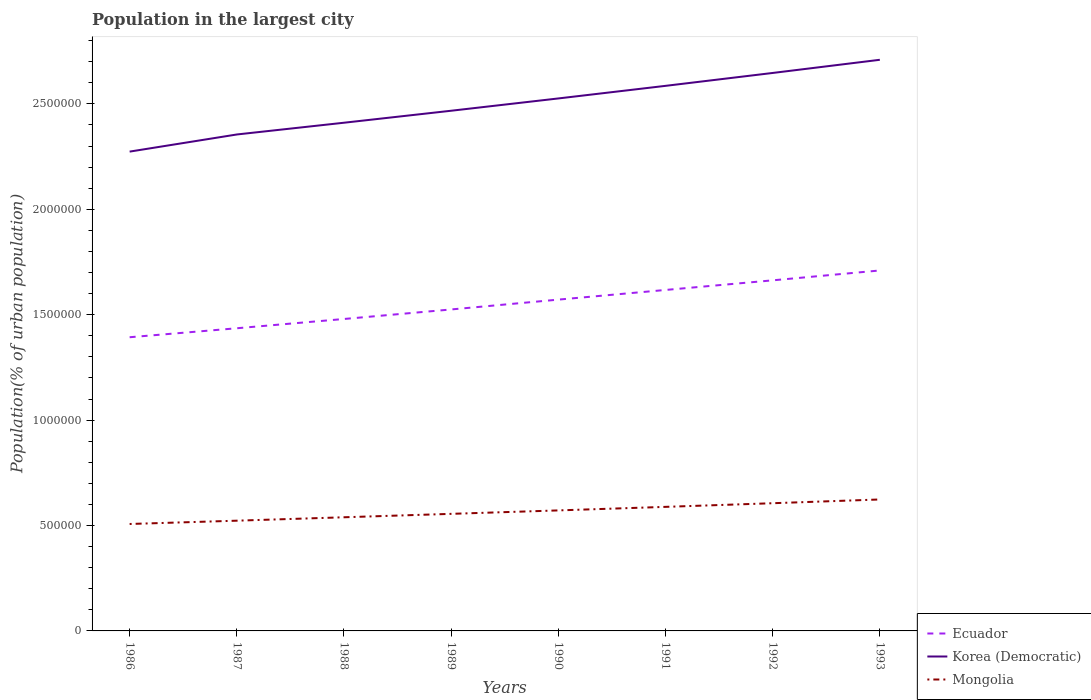Does the line corresponding to Ecuador intersect with the line corresponding to Mongolia?
Provide a succinct answer. No. Is the number of lines equal to the number of legend labels?
Offer a terse response. Yes. Across all years, what is the maximum population in the largest city in Korea (Democratic)?
Keep it short and to the point. 2.27e+06. What is the total population in the largest city in Mongolia in the graph?
Your answer should be compact. -3.26e+04. What is the difference between the highest and the second highest population in the largest city in Korea (Democratic)?
Offer a very short reply. 4.36e+05. How many years are there in the graph?
Provide a short and direct response. 8. What is the difference between two consecutive major ticks on the Y-axis?
Provide a succinct answer. 5.00e+05. Where does the legend appear in the graph?
Your response must be concise. Bottom right. What is the title of the graph?
Ensure brevity in your answer.  Population in the largest city. What is the label or title of the Y-axis?
Your answer should be very brief. Population(% of urban population). What is the Population(% of urban population) of Ecuador in 1986?
Ensure brevity in your answer.  1.39e+06. What is the Population(% of urban population) of Korea (Democratic) in 1986?
Your response must be concise. 2.27e+06. What is the Population(% of urban population) in Mongolia in 1986?
Ensure brevity in your answer.  5.07e+05. What is the Population(% of urban population) in Ecuador in 1987?
Your answer should be compact. 1.44e+06. What is the Population(% of urban population) in Korea (Democratic) in 1987?
Provide a short and direct response. 2.36e+06. What is the Population(% of urban population) in Mongolia in 1987?
Offer a very short reply. 5.23e+05. What is the Population(% of urban population) in Ecuador in 1988?
Your response must be concise. 1.48e+06. What is the Population(% of urban population) in Korea (Democratic) in 1988?
Make the answer very short. 2.41e+06. What is the Population(% of urban population) of Mongolia in 1988?
Offer a very short reply. 5.39e+05. What is the Population(% of urban population) in Ecuador in 1989?
Keep it short and to the point. 1.52e+06. What is the Population(% of urban population) in Korea (Democratic) in 1989?
Provide a short and direct response. 2.47e+06. What is the Population(% of urban population) in Mongolia in 1989?
Your answer should be compact. 5.55e+05. What is the Population(% of urban population) of Ecuador in 1990?
Your response must be concise. 1.57e+06. What is the Population(% of urban population) in Korea (Democratic) in 1990?
Give a very brief answer. 2.53e+06. What is the Population(% of urban population) of Mongolia in 1990?
Your answer should be compact. 5.72e+05. What is the Population(% of urban population) of Ecuador in 1991?
Your answer should be compact. 1.62e+06. What is the Population(% of urban population) of Korea (Democratic) in 1991?
Your answer should be compact. 2.59e+06. What is the Population(% of urban population) of Mongolia in 1991?
Ensure brevity in your answer.  5.88e+05. What is the Population(% of urban population) in Ecuador in 1992?
Offer a terse response. 1.66e+06. What is the Population(% of urban population) of Korea (Democratic) in 1992?
Give a very brief answer. 2.65e+06. What is the Population(% of urban population) in Mongolia in 1992?
Your answer should be very brief. 6.06e+05. What is the Population(% of urban population) of Ecuador in 1993?
Provide a succinct answer. 1.71e+06. What is the Population(% of urban population) of Korea (Democratic) in 1993?
Give a very brief answer. 2.71e+06. What is the Population(% of urban population) of Mongolia in 1993?
Offer a terse response. 6.24e+05. Across all years, what is the maximum Population(% of urban population) of Ecuador?
Ensure brevity in your answer.  1.71e+06. Across all years, what is the maximum Population(% of urban population) of Korea (Democratic)?
Offer a very short reply. 2.71e+06. Across all years, what is the maximum Population(% of urban population) of Mongolia?
Ensure brevity in your answer.  6.24e+05. Across all years, what is the minimum Population(% of urban population) of Ecuador?
Your response must be concise. 1.39e+06. Across all years, what is the minimum Population(% of urban population) of Korea (Democratic)?
Offer a terse response. 2.27e+06. Across all years, what is the minimum Population(% of urban population) of Mongolia?
Offer a terse response. 5.07e+05. What is the total Population(% of urban population) in Ecuador in the graph?
Your response must be concise. 1.24e+07. What is the total Population(% of urban population) of Korea (Democratic) in the graph?
Your response must be concise. 2.00e+07. What is the total Population(% of urban population) of Mongolia in the graph?
Offer a terse response. 4.51e+06. What is the difference between the Population(% of urban population) of Ecuador in 1986 and that in 1987?
Your response must be concise. -4.26e+04. What is the difference between the Population(% of urban population) of Korea (Democratic) in 1986 and that in 1987?
Your response must be concise. -8.12e+04. What is the difference between the Population(% of urban population) of Mongolia in 1986 and that in 1987?
Your answer should be compact. -1.57e+04. What is the difference between the Population(% of urban population) of Ecuador in 1986 and that in 1988?
Provide a succinct answer. -8.66e+04. What is the difference between the Population(% of urban population) of Korea (Democratic) in 1986 and that in 1988?
Make the answer very short. -1.37e+05. What is the difference between the Population(% of urban population) of Mongolia in 1986 and that in 1988?
Keep it short and to the point. -3.19e+04. What is the difference between the Population(% of urban population) in Ecuador in 1986 and that in 1989?
Keep it short and to the point. -1.32e+05. What is the difference between the Population(% of urban population) in Korea (Democratic) in 1986 and that in 1989?
Your answer should be compact. -1.94e+05. What is the difference between the Population(% of urban population) of Mongolia in 1986 and that in 1989?
Make the answer very short. -4.81e+04. What is the difference between the Population(% of urban population) in Ecuador in 1986 and that in 1990?
Your response must be concise. -1.78e+05. What is the difference between the Population(% of urban population) in Korea (Democratic) in 1986 and that in 1990?
Give a very brief answer. -2.52e+05. What is the difference between the Population(% of urban population) in Mongolia in 1986 and that in 1990?
Give a very brief answer. -6.44e+04. What is the difference between the Population(% of urban population) of Ecuador in 1986 and that in 1991?
Provide a short and direct response. -2.24e+05. What is the difference between the Population(% of urban population) in Korea (Democratic) in 1986 and that in 1991?
Your response must be concise. -3.12e+05. What is the difference between the Population(% of urban population) in Mongolia in 1986 and that in 1991?
Keep it short and to the point. -8.12e+04. What is the difference between the Population(% of urban population) in Ecuador in 1986 and that in 1992?
Ensure brevity in your answer.  -2.70e+05. What is the difference between the Population(% of urban population) of Korea (Democratic) in 1986 and that in 1992?
Your answer should be very brief. -3.73e+05. What is the difference between the Population(% of urban population) in Mongolia in 1986 and that in 1992?
Ensure brevity in your answer.  -9.85e+04. What is the difference between the Population(% of urban population) in Ecuador in 1986 and that in 1993?
Provide a succinct answer. -3.17e+05. What is the difference between the Population(% of urban population) in Korea (Democratic) in 1986 and that in 1993?
Offer a terse response. -4.36e+05. What is the difference between the Population(% of urban population) in Mongolia in 1986 and that in 1993?
Offer a terse response. -1.16e+05. What is the difference between the Population(% of urban population) of Ecuador in 1987 and that in 1988?
Ensure brevity in your answer.  -4.40e+04. What is the difference between the Population(% of urban population) of Korea (Democratic) in 1987 and that in 1988?
Your response must be concise. -5.57e+04. What is the difference between the Population(% of urban population) in Mongolia in 1987 and that in 1988?
Offer a very short reply. -1.62e+04. What is the difference between the Population(% of urban population) of Ecuador in 1987 and that in 1989?
Offer a terse response. -8.92e+04. What is the difference between the Population(% of urban population) in Korea (Democratic) in 1987 and that in 1989?
Make the answer very short. -1.13e+05. What is the difference between the Population(% of urban population) of Mongolia in 1987 and that in 1989?
Ensure brevity in your answer.  -3.24e+04. What is the difference between the Population(% of urban population) of Ecuador in 1987 and that in 1990?
Your answer should be very brief. -1.36e+05. What is the difference between the Population(% of urban population) of Korea (Democratic) in 1987 and that in 1990?
Keep it short and to the point. -1.71e+05. What is the difference between the Population(% of urban population) of Mongolia in 1987 and that in 1990?
Ensure brevity in your answer.  -4.87e+04. What is the difference between the Population(% of urban population) in Ecuador in 1987 and that in 1991?
Your answer should be compact. -1.82e+05. What is the difference between the Population(% of urban population) in Korea (Democratic) in 1987 and that in 1991?
Your answer should be compact. -2.31e+05. What is the difference between the Population(% of urban population) in Mongolia in 1987 and that in 1991?
Offer a very short reply. -6.55e+04. What is the difference between the Population(% of urban population) of Ecuador in 1987 and that in 1992?
Ensure brevity in your answer.  -2.27e+05. What is the difference between the Population(% of urban population) of Korea (Democratic) in 1987 and that in 1992?
Your answer should be compact. -2.92e+05. What is the difference between the Population(% of urban population) in Mongolia in 1987 and that in 1992?
Make the answer very short. -8.29e+04. What is the difference between the Population(% of urban population) of Ecuador in 1987 and that in 1993?
Ensure brevity in your answer.  -2.74e+05. What is the difference between the Population(% of urban population) in Korea (Democratic) in 1987 and that in 1993?
Your answer should be compact. -3.54e+05. What is the difference between the Population(% of urban population) of Mongolia in 1987 and that in 1993?
Your response must be concise. -1.01e+05. What is the difference between the Population(% of urban population) in Ecuador in 1988 and that in 1989?
Your answer should be very brief. -4.52e+04. What is the difference between the Population(% of urban population) of Korea (Democratic) in 1988 and that in 1989?
Your response must be concise. -5.69e+04. What is the difference between the Population(% of urban population) in Mongolia in 1988 and that in 1989?
Your answer should be very brief. -1.62e+04. What is the difference between the Population(% of urban population) in Ecuador in 1988 and that in 1990?
Your response must be concise. -9.18e+04. What is the difference between the Population(% of urban population) in Korea (Democratic) in 1988 and that in 1990?
Your answer should be very brief. -1.15e+05. What is the difference between the Population(% of urban population) of Mongolia in 1988 and that in 1990?
Provide a succinct answer. -3.26e+04. What is the difference between the Population(% of urban population) in Ecuador in 1988 and that in 1991?
Your response must be concise. -1.38e+05. What is the difference between the Population(% of urban population) in Korea (Democratic) in 1988 and that in 1991?
Give a very brief answer. -1.75e+05. What is the difference between the Population(% of urban population) of Mongolia in 1988 and that in 1991?
Provide a succinct answer. -4.94e+04. What is the difference between the Population(% of urban population) in Ecuador in 1988 and that in 1992?
Your answer should be very brief. -1.83e+05. What is the difference between the Population(% of urban population) in Korea (Democratic) in 1988 and that in 1992?
Offer a very short reply. -2.36e+05. What is the difference between the Population(% of urban population) of Mongolia in 1988 and that in 1992?
Offer a very short reply. -6.67e+04. What is the difference between the Population(% of urban population) of Ecuador in 1988 and that in 1993?
Make the answer very short. -2.30e+05. What is the difference between the Population(% of urban population) in Korea (Democratic) in 1988 and that in 1993?
Offer a terse response. -2.99e+05. What is the difference between the Population(% of urban population) of Mongolia in 1988 and that in 1993?
Ensure brevity in your answer.  -8.44e+04. What is the difference between the Population(% of urban population) in Ecuador in 1989 and that in 1990?
Offer a very short reply. -4.66e+04. What is the difference between the Population(% of urban population) of Korea (Democratic) in 1989 and that in 1990?
Your answer should be compact. -5.83e+04. What is the difference between the Population(% of urban population) of Mongolia in 1989 and that in 1990?
Offer a terse response. -1.63e+04. What is the difference between the Population(% of urban population) of Ecuador in 1989 and that in 1991?
Ensure brevity in your answer.  -9.25e+04. What is the difference between the Population(% of urban population) of Korea (Democratic) in 1989 and that in 1991?
Provide a short and direct response. -1.18e+05. What is the difference between the Population(% of urban population) in Mongolia in 1989 and that in 1991?
Your answer should be very brief. -3.31e+04. What is the difference between the Population(% of urban population) of Ecuador in 1989 and that in 1992?
Your answer should be compact. -1.38e+05. What is the difference between the Population(% of urban population) in Korea (Democratic) in 1989 and that in 1992?
Your answer should be compact. -1.79e+05. What is the difference between the Population(% of urban population) of Mongolia in 1989 and that in 1992?
Your response must be concise. -5.04e+04. What is the difference between the Population(% of urban population) of Ecuador in 1989 and that in 1993?
Keep it short and to the point. -1.85e+05. What is the difference between the Population(% of urban population) of Korea (Democratic) in 1989 and that in 1993?
Your answer should be compact. -2.42e+05. What is the difference between the Population(% of urban population) in Mongolia in 1989 and that in 1993?
Keep it short and to the point. -6.82e+04. What is the difference between the Population(% of urban population) of Ecuador in 1990 and that in 1991?
Provide a succinct answer. -4.58e+04. What is the difference between the Population(% of urban population) in Korea (Democratic) in 1990 and that in 1991?
Provide a succinct answer. -5.97e+04. What is the difference between the Population(% of urban population) of Mongolia in 1990 and that in 1991?
Offer a terse response. -1.68e+04. What is the difference between the Population(% of urban population) in Ecuador in 1990 and that in 1992?
Ensure brevity in your answer.  -9.15e+04. What is the difference between the Population(% of urban population) in Korea (Democratic) in 1990 and that in 1992?
Your answer should be very brief. -1.21e+05. What is the difference between the Population(% of urban population) in Mongolia in 1990 and that in 1992?
Your response must be concise. -3.41e+04. What is the difference between the Population(% of urban population) in Ecuador in 1990 and that in 1993?
Provide a short and direct response. -1.38e+05. What is the difference between the Population(% of urban population) of Korea (Democratic) in 1990 and that in 1993?
Offer a terse response. -1.83e+05. What is the difference between the Population(% of urban population) in Mongolia in 1990 and that in 1993?
Provide a short and direct response. -5.19e+04. What is the difference between the Population(% of urban population) of Ecuador in 1991 and that in 1992?
Offer a very short reply. -4.57e+04. What is the difference between the Population(% of urban population) of Korea (Democratic) in 1991 and that in 1992?
Offer a terse response. -6.12e+04. What is the difference between the Population(% of urban population) of Mongolia in 1991 and that in 1992?
Your answer should be very brief. -1.73e+04. What is the difference between the Population(% of urban population) in Ecuador in 1991 and that in 1993?
Offer a terse response. -9.25e+04. What is the difference between the Population(% of urban population) of Korea (Democratic) in 1991 and that in 1993?
Provide a succinct answer. -1.24e+05. What is the difference between the Population(% of urban population) in Mongolia in 1991 and that in 1993?
Keep it short and to the point. -3.51e+04. What is the difference between the Population(% of urban population) in Ecuador in 1992 and that in 1993?
Make the answer very short. -4.68e+04. What is the difference between the Population(% of urban population) of Korea (Democratic) in 1992 and that in 1993?
Your answer should be very brief. -6.25e+04. What is the difference between the Population(% of urban population) of Mongolia in 1992 and that in 1993?
Offer a terse response. -1.78e+04. What is the difference between the Population(% of urban population) in Ecuador in 1986 and the Population(% of urban population) in Korea (Democratic) in 1987?
Your answer should be compact. -9.62e+05. What is the difference between the Population(% of urban population) in Ecuador in 1986 and the Population(% of urban population) in Mongolia in 1987?
Offer a terse response. 8.70e+05. What is the difference between the Population(% of urban population) of Korea (Democratic) in 1986 and the Population(% of urban population) of Mongolia in 1987?
Keep it short and to the point. 1.75e+06. What is the difference between the Population(% of urban population) in Ecuador in 1986 and the Population(% of urban population) in Korea (Democratic) in 1988?
Make the answer very short. -1.02e+06. What is the difference between the Population(% of urban population) of Ecuador in 1986 and the Population(% of urban population) of Mongolia in 1988?
Your answer should be very brief. 8.54e+05. What is the difference between the Population(% of urban population) in Korea (Democratic) in 1986 and the Population(% of urban population) in Mongolia in 1988?
Make the answer very short. 1.73e+06. What is the difference between the Population(% of urban population) of Ecuador in 1986 and the Population(% of urban population) of Korea (Democratic) in 1989?
Offer a terse response. -1.07e+06. What is the difference between the Population(% of urban population) in Ecuador in 1986 and the Population(% of urban population) in Mongolia in 1989?
Make the answer very short. 8.38e+05. What is the difference between the Population(% of urban population) in Korea (Democratic) in 1986 and the Population(% of urban population) in Mongolia in 1989?
Offer a very short reply. 1.72e+06. What is the difference between the Population(% of urban population) in Ecuador in 1986 and the Population(% of urban population) in Korea (Democratic) in 1990?
Keep it short and to the point. -1.13e+06. What is the difference between the Population(% of urban population) of Ecuador in 1986 and the Population(% of urban population) of Mongolia in 1990?
Offer a terse response. 8.21e+05. What is the difference between the Population(% of urban population) of Korea (Democratic) in 1986 and the Population(% of urban population) of Mongolia in 1990?
Ensure brevity in your answer.  1.70e+06. What is the difference between the Population(% of urban population) in Ecuador in 1986 and the Population(% of urban population) in Korea (Democratic) in 1991?
Make the answer very short. -1.19e+06. What is the difference between the Population(% of urban population) in Ecuador in 1986 and the Population(% of urban population) in Mongolia in 1991?
Ensure brevity in your answer.  8.05e+05. What is the difference between the Population(% of urban population) in Korea (Democratic) in 1986 and the Population(% of urban population) in Mongolia in 1991?
Your answer should be compact. 1.69e+06. What is the difference between the Population(% of urban population) in Ecuador in 1986 and the Population(% of urban population) in Korea (Democratic) in 1992?
Provide a succinct answer. -1.25e+06. What is the difference between the Population(% of urban population) of Ecuador in 1986 and the Population(% of urban population) of Mongolia in 1992?
Your answer should be very brief. 7.87e+05. What is the difference between the Population(% of urban population) in Korea (Democratic) in 1986 and the Population(% of urban population) in Mongolia in 1992?
Your answer should be very brief. 1.67e+06. What is the difference between the Population(% of urban population) in Ecuador in 1986 and the Population(% of urban population) in Korea (Democratic) in 1993?
Your response must be concise. -1.32e+06. What is the difference between the Population(% of urban population) of Ecuador in 1986 and the Population(% of urban population) of Mongolia in 1993?
Keep it short and to the point. 7.70e+05. What is the difference between the Population(% of urban population) of Korea (Democratic) in 1986 and the Population(% of urban population) of Mongolia in 1993?
Provide a succinct answer. 1.65e+06. What is the difference between the Population(% of urban population) of Ecuador in 1987 and the Population(% of urban population) of Korea (Democratic) in 1988?
Ensure brevity in your answer.  -9.75e+05. What is the difference between the Population(% of urban population) of Ecuador in 1987 and the Population(% of urban population) of Mongolia in 1988?
Provide a succinct answer. 8.97e+05. What is the difference between the Population(% of urban population) in Korea (Democratic) in 1987 and the Population(% of urban population) in Mongolia in 1988?
Make the answer very short. 1.82e+06. What is the difference between the Population(% of urban population) of Ecuador in 1987 and the Population(% of urban population) of Korea (Democratic) in 1989?
Keep it short and to the point. -1.03e+06. What is the difference between the Population(% of urban population) of Ecuador in 1987 and the Population(% of urban population) of Mongolia in 1989?
Provide a succinct answer. 8.80e+05. What is the difference between the Population(% of urban population) in Korea (Democratic) in 1987 and the Population(% of urban population) in Mongolia in 1989?
Your response must be concise. 1.80e+06. What is the difference between the Population(% of urban population) in Ecuador in 1987 and the Population(% of urban population) in Korea (Democratic) in 1990?
Keep it short and to the point. -1.09e+06. What is the difference between the Population(% of urban population) of Ecuador in 1987 and the Population(% of urban population) of Mongolia in 1990?
Provide a succinct answer. 8.64e+05. What is the difference between the Population(% of urban population) of Korea (Democratic) in 1987 and the Population(% of urban population) of Mongolia in 1990?
Give a very brief answer. 1.78e+06. What is the difference between the Population(% of urban population) in Ecuador in 1987 and the Population(% of urban population) in Korea (Democratic) in 1991?
Your answer should be very brief. -1.15e+06. What is the difference between the Population(% of urban population) in Ecuador in 1987 and the Population(% of urban population) in Mongolia in 1991?
Provide a succinct answer. 8.47e+05. What is the difference between the Population(% of urban population) of Korea (Democratic) in 1987 and the Population(% of urban population) of Mongolia in 1991?
Your response must be concise. 1.77e+06. What is the difference between the Population(% of urban population) in Ecuador in 1987 and the Population(% of urban population) in Korea (Democratic) in 1992?
Offer a terse response. -1.21e+06. What is the difference between the Population(% of urban population) of Ecuador in 1987 and the Population(% of urban population) of Mongolia in 1992?
Your answer should be compact. 8.30e+05. What is the difference between the Population(% of urban population) in Korea (Democratic) in 1987 and the Population(% of urban population) in Mongolia in 1992?
Provide a succinct answer. 1.75e+06. What is the difference between the Population(% of urban population) in Ecuador in 1987 and the Population(% of urban population) in Korea (Democratic) in 1993?
Keep it short and to the point. -1.27e+06. What is the difference between the Population(% of urban population) of Ecuador in 1987 and the Population(% of urban population) of Mongolia in 1993?
Keep it short and to the point. 8.12e+05. What is the difference between the Population(% of urban population) of Korea (Democratic) in 1987 and the Population(% of urban population) of Mongolia in 1993?
Your response must be concise. 1.73e+06. What is the difference between the Population(% of urban population) of Ecuador in 1988 and the Population(% of urban population) of Korea (Democratic) in 1989?
Your answer should be compact. -9.88e+05. What is the difference between the Population(% of urban population) in Ecuador in 1988 and the Population(% of urban population) in Mongolia in 1989?
Ensure brevity in your answer.  9.24e+05. What is the difference between the Population(% of urban population) in Korea (Democratic) in 1988 and the Population(% of urban population) in Mongolia in 1989?
Provide a short and direct response. 1.86e+06. What is the difference between the Population(% of urban population) of Ecuador in 1988 and the Population(% of urban population) of Korea (Democratic) in 1990?
Give a very brief answer. -1.05e+06. What is the difference between the Population(% of urban population) of Ecuador in 1988 and the Population(% of urban population) of Mongolia in 1990?
Your response must be concise. 9.08e+05. What is the difference between the Population(% of urban population) in Korea (Democratic) in 1988 and the Population(% of urban population) in Mongolia in 1990?
Offer a very short reply. 1.84e+06. What is the difference between the Population(% of urban population) of Ecuador in 1988 and the Population(% of urban population) of Korea (Democratic) in 1991?
Offer a terse response. -1.11e+06. What is the difference between the Population(% of urban population) of Ecuador in 1988 and the Population(% of urban population) of Mongolia in 1991?
Your answer should be very brief. 8.91e+05. What is the difference between the Population(% of urban population) of Korea (Democratic) in 1988 and the Population(% of urban population) of Mongolia in 1991?
Offer a terse response. 1.82e+06. What is the difference between the Population(% of urban population) in Ecuador in 1988 and the Population(% of urban population) in Korea (Democratic) in 1992?
Provide a short and direct response. -1.17e+06. What is the difference between the Population(% of urban population) in Ecuador in 1988 and the Population(% of urban population) in Mongolia in 1992?
Offer a very short reply. 8.74e+05. What is the difference between the Population(% of urban population) in Korea (Democratic) in 1988 and the Population(% of urban population) in Mongolia in 1992?
Provide a short and direct response. 1.80e+06. What is the difference between the Population(% of urban population) of Ecuador in 1988 and the Population(% of urban population) of Korea (Democratic) in 1993?
Offer a terse response. -1.23e+06. What is the difference between the Population(% of urban population) of Ecuador in 1988 and the Population(% of urban population) of Mongolia in 1993?
Your answer should be very brief. 8.56e+05. What is the difference between the Population(% of urban population) of Korea (Democratic) in 1988 and the Population(% of urban population) of Mongolia in 1993?
Your answer should be compact. 1.79e+06. What is the difference between the Population(% of urban population) in Ecuador in 1989 and the Population(% of urban population) in Korea (Democratic) in 1990?
Provide a succinct answer. -1.00e+06. What is the difference between the Population(% of urban population) of Ecuador in 1989 and the Population(% of urban population) of Mongolia in 1990?
Keep it short and to the point. 9.53e+05. What is the difference between the Population(% of urban population) in Korea (Democratic) in 1989 and the Population(% of urban population) in Mongolia in 1990?
Keep it short and to the point. 1.90e+06. What is the difference between the Population(% of urban population) of Ecuador in 1989 and the Population(% of urban population) of Korea (Democratic) in 1991?
Your answer should be compact. -1.06e+06. What is the difference between the Population(% of urban population) in Ecuador in 1989 and the Population(% of urban population) in Mongolia in 1991?
Make the answer very short. 9.36e+05. What is the difference between the Population(% of urban population) in Korea (Democratic) in 1989 and the Population(% of urban population) in Mongolia in 1991?
Provide a short and direct response. 1.88e+06. What is the difference between the Population(% of urban population) of Ecuador in 1989 and the Population(% of urban population) of Korea (Democratic) in 1992?
Your answer should be very brief. -1.12e+06. What is the difference between the Population(% of urban population) in Ecuador in 1989 and the Population(% of urban population) in Mongolia in 1992?
Offer a terse response. 9.19e+05. What is the difference between the Population(% of urban population) of Korea (Democratic) in 1989 and the Population(% of urban population) of Mongolia in 1992?
Your answer should be compact. 1.86e+06. What is the difference between the Population(% of urban population) in Ecuador in 1989 and the Population(% of urban population) in Korea (Democratic) in 1993?
Provide a short and direct response. -1.18e+06. What is the difference between the Population(% of urban population) in Ecuador in 1989 and the Population(% of urban population) in Mongolia in 1993?
Your answer should be very brief. 9.01e+05. What is the difference between the Population(% of urban population) in Korea (Democratic) in 1989 and the Population(% of urban population) in Mongolia in 1993?
Offer a very short reply. 1.84e+06. What is the difference between the Population(% of urban population) of Ecuador in 1990 and the Population(% of urban population) of Korea (Democratic) in 1991?
Ensure brevity in your answer.  -1.01e+06. What is the difference between the Population(% of urban population) of Ecuador in 1990 and the Population(% of urban population) of Mongolia in 1991?
Make the answer very short. 9.83e+05. What is the difference between the Population(% of urban population) of Korea (Democratic) in 1990 and the Population(% of urban population) of Mongolia in 1991?
Keep it short and to the point. 1.94e+06. What is the difference between the Population(% of urban population) in Ecuador in 1990 and the Population(% of urban population) in Korea (Democratic) in 1992?
Keep it short and to the point. -1.08e+06. What is the difference between the Population(% of urban population) of Ecuador in 1990 and the Population(% of urban population) of Mongolia in 1992?
Offer a very short reply. 9.66e+05. What is the difference between the Population(% of urban population) of Korea (Democratic) in 1990 and the Population(% of urban population) of Mongolia in 1992?
Your answer should be compact. 1.92e+06. What is the difference between the Population(% of urban population) of Ecuador in 1990 and the Population(% of urban population) of Korea (Democratic) in 1993?
Your answer should be very brief. -1.14e+06. What is the difference between the Population(% of urban population) of Ecuador in 1990 and the Population(% of urban population) of Mongolia in 1993?
Offer a terse response. 9.48e+05. What is the difference between the Population(% of urban population) in Korea (Democratic) in 1990 and the Population(% of urban population) in Mongolia in 1993?
Give a very brief answer. 1.90e+06. What is the difference between the Population(% of urban population) in Ecuador in 1991 and the Population(% of urban population) in Korea (Democratic) in 1992?
Keep it short and to the point. -1.03e+06. What is the difference between the Population(% of urban population) of Ecuador in 1991 and the Population(% of urban population) of Mongolia in 1992?
Make the answer very short. 1.01e+06. What is the difference between the Population(% of urban population) of Korea (Democratic) in 1991 and the Population(% of urban population) of Mongolia in 1992?
Ensure brevity in your answer.  1.98e+06. What is the difference between the Population(% of urban population) of Ecuador in 1991 and the Population(% of urban population) of Korea (Democratic) in 1993?
Keep it short and to the point. -1.09e+06. What is the difference between the Population(% of urban population) in Ecuador in 1991 and the Population(% of urban population) in Mongolia in 1993?
Provide a short and direct response. 9.94e+05. What is the difference between the Population(% of urban population) of Korea (Democratic) in 1991 and the Population(% of urban population) of Mongolia in 1993?
Your answer should be very brief. 1.96e+06. What is the difference between the Population(% of urban population) of Ecuador in 1992 and the Population(% of urban population) of Korea (Democratic) in 1993?
Offer a very short reply. -1.05e+06. What is the difference between the Population(% of urban population) of Ecuador in 1992 and the Population(% of urban population) of Mongolia in 1993?
Ensure brevity in your answer.  1.04e+06. What is the difference between the Population(% of urban population) of Korea (Democratic) in 1992 and the Population(% of urban population) of Mongolia in 1993?
Offer a very short reply. 2.02e+06. What is the average Population(% of urban population) in Ecuador per year?
Your response must be concise. 1.55e+06. What is the average Population(% of urban population) of Korea (Democratic) per year?
Provide a succinct answer. 2.50e+06. What is the average Population(% of urban population) in Mongolia per year?
Give a very brief answer. 5.64e+05. In the year 1986, what is the difference between the Population(% of urban population) in Ecuador and Population(% of urban population) in Korea (Democratic)?
Give a very brief answer. -8.81e+05. In the year 1986, what is the difference between the Population(% of urban population) in Ecuador and Population(% of urban population) in Mongolia?
Offer a terse response. 8.86e+05. In the year 1986, what is the difference between the Population(% of urban population) of Korea (Democratic) and Population(% of urban population) of Mongolia?
Provide a succinct answer. 1.77e+06. In the year 1987, what is the difference between the Population(% of urban population) of Ecuador and Population(% of urban population) of Korea (Democratic)?
Your answer should be very brief. -9.19e+05. In the year 1987, what is the difference between the Population(% of urban population) in Ecuador and Population(% of urban population) in Mongolia?
Offer a terse response. 9.13e+05. In the year 1987, what is the difference between the Population(% of urban population) in Korea (Democratic) and Population(% of urban population) in Mongolia?
Ensure brevity in your answer.  1.83e+06. In the year 1988, what is the difference between the Population(% of urban population) of Ecuador and Population(% of urban population) of Korea (Democratic)?
Your answer should be very brief. -9.31e+05. In the year 1988, what is the difference between the Population(% of urban population) in Ecuador and Population(% of urban population) in Mongolia?
Provide a succinct answer. 9.41e+05. In the year 1988, what is the difference between the Population(% of urban population) in Korea (Democratic) and Population(% of urban population) in Mongolia?
Offer a terse response. 1.87e+06. In the year 1989, what is the difference between the Population(% of urban population) of Ecuador and Population(% of urban population) of Korea (Democratic)?
Your response must be concise. -9.43e+05. In the year 1989, what is the difference between the Population(% of urban population) in Ecuador and Population(% of urban population) in Mongolia?
Offer a terse response. 9.70e+05. In the year 1989, what is the difference between the Population(% of urban population) of Korea (Democratic) and Population(% of urban population) of Mongolia?
Offer a very short reply. 1.91e+06. In the year 1990, what is the difference between the Population(% of urban population) of Ecuador and Population(% of urban population) of Korea (Democratic)?
Your answer should be very brief. -9.54e+05. In the year 1990, what is the difference between the Population(% of urban population) of Ecuador and Population(% of urban population) of Mongolia?
Provide a succinct answer. 1.00e+06. In the year 1990, what is the difference between the Population(% of urban population) of Korea (Democratic) and Population(% of urban population) of Mongolia?
Your response must be concise. 1.95e+06. In the year 1991, what is the difference between the Population(% of urban population) of Ecuador and Population(% of urban population) of Korea (Democratic)?
Make the answer very short. -9.68e+05. In the year 1991, what is the difference between the Population(% of urban population) of Ecuador and Population(% of urban population) of Mongolia?
Your answer should be very brief. 1.03e+06. In the year 1991, what is the difference between the Population(% of urban population) of Korea (Democratic) and Population(% of urban population) of Mongolia?
Offer a terse response. 2.00e+06. In the year 1992, what is the difference between the Population(% of urban population) of Ecuador and Population(% of urban population) of Korea (Democratic)?
Your answer should be compact. -9.84e+05. In the year 1992, what is the difference between the Population(% of urban population) in Ecuador and Population(% of urban population) in Mongolia?
Offer a terse response. 1.06e+06. In the year 1992, what is the difference between the Population(% of urban population) of Korea (Democratic) and Population(% of urban population) of Mongolia?
Your answer should be compact. 2.04e+06. In the year 1993, what is the difference between the Population(% of urban population) of Ecuador and Population(% of urban population) of Korea (Democratic)?
Offer a very short reply. -9.99e+05. In the year 1993, what is the difference between the Population(% of urban population) in Ecuador and Population(% of urban population) in Mongolia?
Provide a short and direct response. 1.09e+06. In the year 1993, what is the difference between the Population(% of urban population) of Korea (Democratic) and Population(% of urban population) of Mongolia?
Give a very brief answer. 2.09e+06. What is the ratio of the Population(% of urban population) in Ecuador in 1986 to that in 1987?
Offer a terse response. 0.97. What is the ratio of the Population(% of urban population) in Korea (Democratic) in 1986 to that in 1987?
Your answer should be very brief. 0.97. What is the ratio of the Population(% of urban population) in Ecuador in 1986 to that in 1988?
Your answer should be very brief. 0.94. What is the ratio of the Population(% of urban population) in Korea (Democratic) in 1986 to that in 1988?
Your answer should be compact. 0.94. What is the ratio of the Population(% of urban population) in Mongolia in 1986 to that in 1988?
Make the answer very short. 0.94. What is the ratio of the Population(% of urban population) of Ecuador in 1986 to that in 1989?
Your answer should be compact. 0.91. What is the ratio of the Population(% of urban population) of Korea (Democratic) in 1986 to that in 1989?
Offer a very short reply. 0.92. What is the ratio of the Population(% of urban population) of Mongolia in 1986 to that in 1989?
Offer a very short reply. 0.91. What is the ratio of the Population(% of urban population) of Ecuador in 1986 to that in 1990?
Your answer should be compact. 0.89. What is the ratio of the Population(% of urban population) in Korea (Democratic) in 1986 to that in 1990?
Provide a short and direct response. 0.9. What is the ratio of the Population(% of urban population) in Mongolia in 1986 to that in 1990?
Provide a short and direct response. 0.89. What is the ratio of the Population(% of urban population) of Ecuador in 1986 to that in 1991?
Your response must be concise. 0.86. What is the ratio of the Population(% of urban population) in Korea (Democratic) in 1986 to that in 1991?
Offer a very short reply. 0.88. What is the ratio of the Population(% of urban population) of Mongolia in 1986 to that in 1991?
Your response must be concise. 0.86. What is the ratio of the Population(% of urban population) of Ecuador in 1986 to that in 1992?
Keep it short and to the point. 0.84. What is the ratio of the Population(% of urban population) of Korea (Democratic) in 1986 to that in 1992?
Offer a very short reply. 0.86. What is the ratio of the Population(% of urban population) in Mongolia in 1986 to that in 1992?
Offer a very short reply. 0.84. What is the ratio of the Population(% of urban population) of Ecuador in 1986 to that in 1993?
Provide a succinct answer. 0.81. What is the ratio of the Population(% of urban population) of Korea (Democratic) in 1986 to that in 1993?
Offer a terse response. 0.84. What is the ratio of the Population(% of urban population) of Mongolia in 1986 to that in 1993?
Provide a succinct answer. 0.81. What is the ratio of the Population(% of urban population) of Ecuador in 1987 to that in 1988?
Your response must be concise. 0.97. What is the ratio of the Population(% of urban population) in Korea (Democratic) in 1987 to that in 1988?
Offer a very short reply. 0.98. What is the ratio of the Population(% of urban population) of Mongolia in 1987 to that in 1988?
Your answer should be compact. 0.97. What is the ratio of the Population(% of urban population) in Ecuador in 1987 to that in 1989?
Provide a short and direct response. 0.94. What is the ratio of the Population(% of urban population) of Korea (Democratic) in 1987 to that in 1989?
Your response must be concise. 0.95. What is the ratio of the Population(% of urban population) in Mongolia in 1987 to that in 1989?
Your answer should be compact. 0.94. What is the ratio of the Population(% of urban population) in Ecuador in 1987 to that in 1990?
Make the answer very short. 0.91. What is the ratio of the Population(% of urban population) of Korea (Democratic) in 1987 to that in 1990?
Provide a short and direct response. 0.93. What is the ratio of the Population(% of urban population) in Mongolia in 1987 to that in 1990?
Provide a succinct answer. 0.91. What is the ratio of the Population(% of urban population) of Ecuador in 1987 to that in 1991?
Give a very brief answer. 0.89. What is the ratio of the Population(% of urban population) of Korea (Democratic) in 1987 to that in 1991?
Your answer should be compact. 0.91. What is the ratio of the Population(% of urban population) of Mongolia in 1987 to that in 1991?
Provide a short and direct response. 0.89. What is the ratio of the Population(% of urban population) of Ecuador in 1987 to that in 1992?
Make the answer very short. 0.86. What is the ratio of the Population(% of urban population) of Korea (Democratic) in 1987 to that in 1992?
Provide a short and direct response. 0.89. What is the ratio of the Population(% of urban population) in Mongolia in 1987 to that in 1992?
Provide a short and direct response. 0.86. What is the ratio of the Population(% of urban population) in Ecuador in 1987 to that in 1993?
Give a very brief answer. 0.84. What is the ratio of the Population(% of urban population) of Korea (Democratic) in 1987 to that in 1993?
Make the answer very short. 0.87. What is the ratio of the Population(% of urban population) of Mongolia in 1987 to that in 1993?
Provide a succinct answer. 0.84. What is the ratio of the Population(% of urban population) in Ecuador in 1988 to that in 1989?
Ensure brevity in your answer.  0.97. What is the ratio of the Population(% of urban population) of Korea (Democratic) in 1988 to that in 1989?
Make the answer very short. 0.98. What is the ratio of the Population(% of urban population) in Mongolia in 1988 to that in 1989?
Your answer should be very brief. 0.97. What is the ratio of the Population(% of urban population) of Ecuador in 1988 to that in 1990?
Provide a short and direct response. 0.94. What is the ratio of the Population(% of urban population) of Korea (Democratic) in 1988 to that in 1990?
Your response must be concise. 0.95. What is the ratio of the Population(% of urban population) in Mongolia in 1988 to that in 1990?
Make the answer very short. 0.94. What is the ratio of the Population(% of urban population) in Ecuador in 1988 to that in 1991?
Your answer should be very brief. 0.91. What is the ratio of the Population(% of urban population) of Korea (Democratic) in 1988 to that in 1991?
Your answer should be very brief. 0.93. What is the ratio of the Population(% of urban population) in Mongolia in 1988 to that in 1991?
Ensure brevity in your answer.  0.92. What is the ratio of the Population(% of urban population) in Ecuador in 1988 to that in 1992?
Offer a terse response. 0.89. What is the ratio of the Population(% of urban population) in Korea (Democratic) in 1988 to that in 1992?
Make the answer very short. 0.91. What is the ratio of the Population(% of urban population) of Mongolia in 1988 to that in 1992?
Offer a very short reply. 0.89. What is the ratio of the Population(% of urban population) in Ecuador in 1988 to that in 1993?
Give a very brief answer. 0.87. What is the ratio of the Population(% of urban population) of Korea (Democratic) in 1988 to that in 1993?
Keep it short and to the point. 0.89. What is the ratio of the Population(% of urban population) in Mongolia in 1988 to that in 1993?
Provide a short and direct response. 0.86. What is the ratio of the Population(% of urban population) of Ecuador in 1989 to that in 1990?
Keep it short and to the point. 0.97. What is the ratio of the Population(% of urban population) of Korea (Democratic) in 1989 to that in 1990?
Offer a very short reply. 0.98. What is the ratio of the Population(% of urban population) of Mongolia in 1989 to that in 1990?
Give a very brief answer. 0.97. What is the ratio of the Population(% of urban population) in Ecuador in 1989 to that in 1991?
Your answer should be very brief. 0.94. What is the ratio of the Population(% of urban population) in Korea (Democratic) in 1989 to that in 1991?
Give a very brief answer. 0.95. What is the ratio of the Population(% of urban population) in Mongolia in 1989 to that in 1991?
Your response must be concise. 0.94. What is the ratio of the Population(% of urban population) of Ecuador in 1989 to that in 1992?
Keep it short and to the point. 0.92. What is the ratio of the Population(% of urban population) in Korea (Democratic) in 1989 to that in 1992?
Ensure brevity in your answer.  0.93. What is the ratio of the Population(% of urban population) of Ecuador in 1989 to that in 1993?
Your answer should be very brief. 0.89. What is the ratio of the Population(% of urban population) in Korea (Democratic) in 1989 to that in 1993?
Provide a short and direct response. 0.91. What is the ratio of the Population(% of urban population) in Mongolia in 1989 to that in 1993?
Make the answer very short. 0.89. What is the ratio of the Population(% of urban population) of Ecuador in 1990 to that in 1991?
Provide a succinct answer. 0.97. What is the ratio of the Population(% of urban population) in Korea (Democratic) in 1990 to that in 1991?
Provide a short and direct response. 0.98. What is the ratio of the Population(% of urban population) of Mongolia in 1990 to that in 1991?
Your response must be concise. 0.97. What is the ratio of the Population(% of urban population) in Ecuador in 1990 to that in 1992?
Offer a very short reply. 0.94. What is the ratio of the Population(% of urban population) in Korea (Democratic) in 1990 to that in 1992?
Your answer should be compact. 0.95. What is the ratio of the Population(% of urban population) in Mongolia in 1990 to that in 1992?
Provide a succinct answer. 0.94. What is the ratio of the Population(% of urban population) of Ecuador in 1990 to that in 1993?
Provide a short and direct response. 0.92. What is the ratio of the Population(% of urban population) in Korea (Democratic) in 1990 to that in 1993?
Make the answer very short. 0.93. What is the ratio of the Population(% of urban population) in Mongolia in 1990 to that in 1993?
Offer a terse response. 0.92. What is the ratio of the Population(% of urban population) in Ecuador in 1991 to that in 1992?
Your response must be concise. 0.97. What is the ratio of the Population(% of urban population) in Korea (Democratic) in 1991 to that in 1992?
Your answer should be compact. 0.98. What is the ratio of the Population(% of urban population) of Mongolia in 1991 to that in 1992?
Your response must be concise. 0.97. What is the ratio of the Population(% of urban population) in Ecuador in 1991 to that in 1993?
Keep it short and to the point. 0.95. What is the ratio of the Population(% of urban population) in Korea (Democratic) in 1991 to that in 1993?
Your answer should be compact. 0.95. What is the ratio of the Population(% of urban population) in Mongolia in 1991 to that in 1993?
Make the answer very short. 0.94. What is the ratio of the Population(% of urban population) of Ecuador in 1992 to that in 1993?
Offer a terse response. 0.97. What is the ratio of the Population(% of urban population) in Korea (Democratic) in 1992 to that in 1993?
Offer a terse response. 0.98. What is the ratio of the Population(% of urban population) of Mongolia in 1992 to that in 1993?
Make the answer very short. 0.97. What is the difference between the highest and the second highest Population(% of urban population) in Ecuador?
Give a very brief answer. 4.68e+04. What is the difference between the highest and the second highest Population(% of urban population) of Korea (Democratic)?
Give a very brief answer. 6.25e+04. What is the difference between the highest and the second highest Population(% of urban population) of Mongolia?
Make the answer very short. 1.78e+04. What is the difference between the highest and the lowest Population(% of urban population) in Ecuador?
Make the answer very short. 3.17e+05. What is the difference between the highest and the lowest Population(% of urban population) in Korea (Democratic)?
Give a very brief answer. 4.36e+05. What is the difference between the highest and the lowest Population(% of urban population) in Mongolia?
Your answer should be compact. 1.16e+05. 